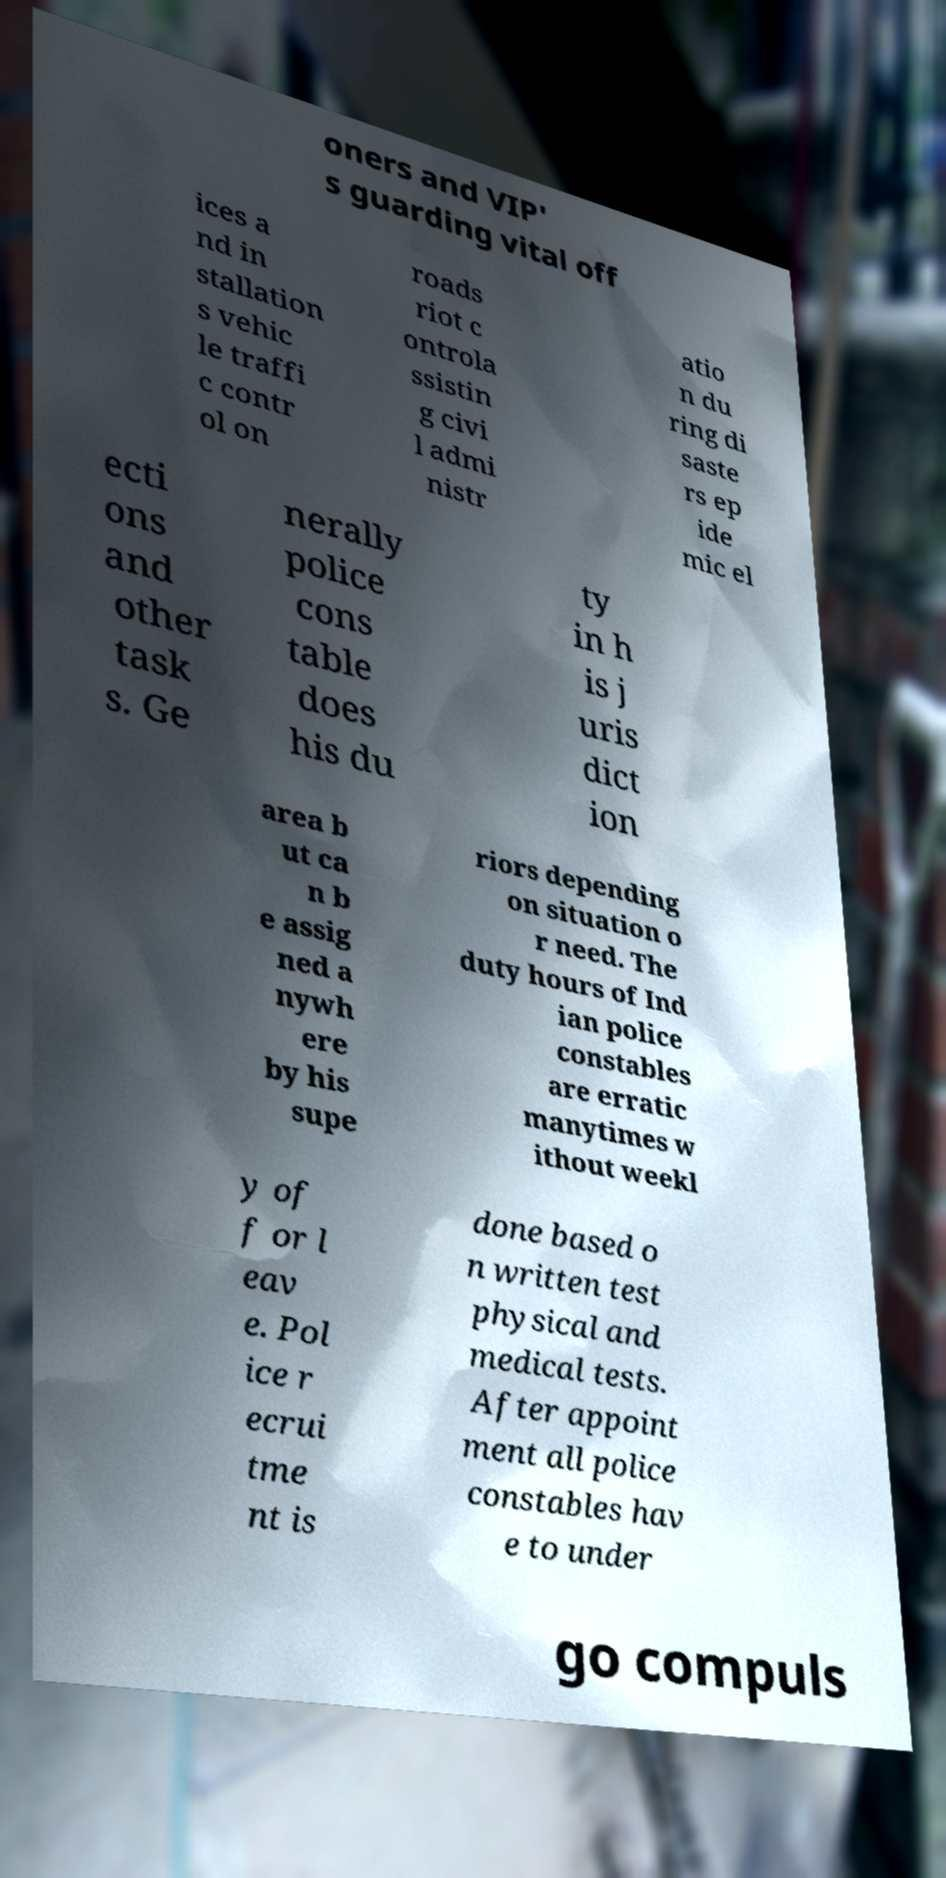I need the written content from this picture converted into text. Can you do that? oners and VIP' s guarding vital off ices a nd in stallation s vehic le traffi c contr ol on roads riot c ontrola ssistin g civi l admi nistr atio n du ring di saste rs ep ide mic el ecti ons and other task s. Ge nerally police cons table does his du ty in h is j uris dict ion area b ut ca n b e assig ned a nywh ere by his supe riors depending on situation o r need. The duty hours of Ind ian police constables are erratic manytimes w ithout weekl y of f or l eav e. Pol ice r ecrui tme nt is done based o n written test physical and medical tests. After appoint ment all police constables hav e to under go compuls 